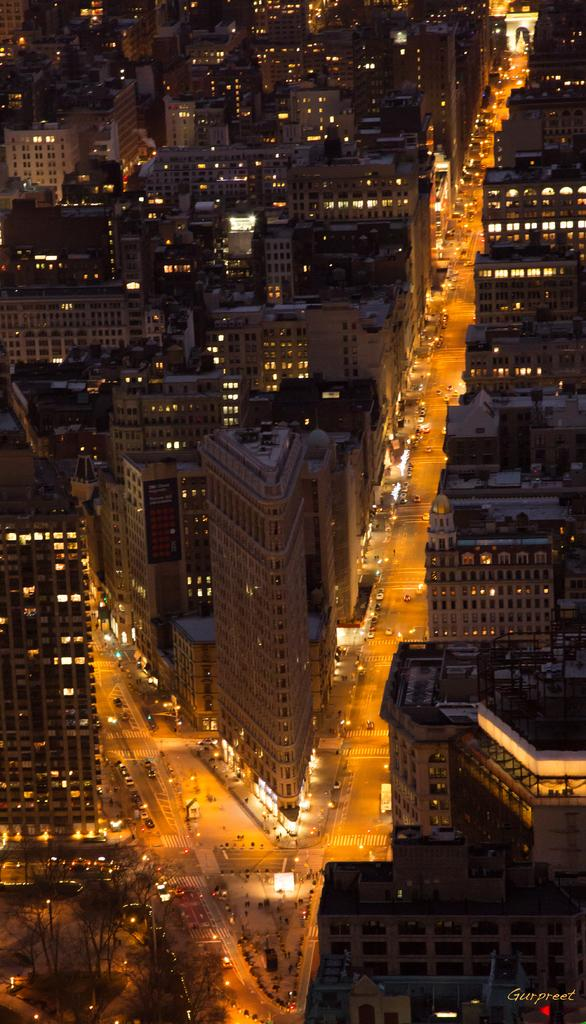What type of structures can be seen in the image? There are buildings in the image. What else is visible in the image besides the buildings? There are lights, trees, vehicles on the road, and text in the bottom right side of the image. Can you describe the lighting in the image? Yes, there are lights visible in the image. What type of transportation can be seen on the road in the image? There are vehicles on the road in the image. Where is the rabbit hiding in the image? There is no rabbit present in the image. What type of pan is being used to cook in the image? There is no pan or cooking activity depicted in the image. 